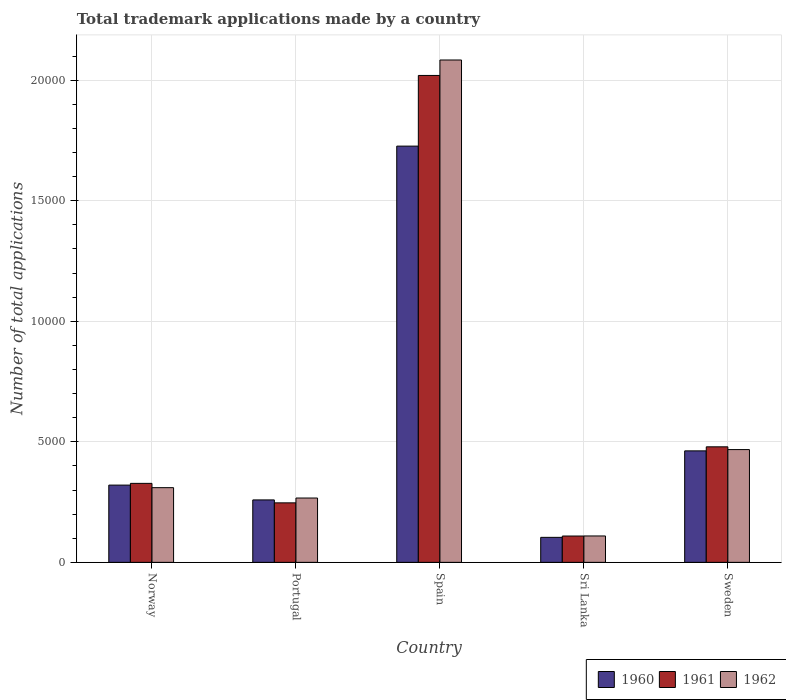How many different coloured bars are there?
Provide a succinct answer. 3. How many groups of bars are there?
Ensure brevity in your answer.  5. Are the number of bars per tick equal to the number of legend labels?
Your answer should be compact. Yes. How many bars are there on the 3rd tick from the left?
Your answer should be very brief. 3. What is the label of the 5th group of bars from the left?
Offer a terse response. Sweden. What is the number of applications made by in 1962 in Norway?
Your answer should be compact. 3098. Across all countries, what is the maximum number of applications made by in 1962?
Your response must be concise. 2.08e+04. Across all countries, what is the minimum number of applications made by in 1961?
Provide a succinct answer. 1092. In which country was the number of applications made by in 1962 maximum?
Make the answer very short. Spain. In which country was the number of applications made by in 1960 minimum?
Make the answer very short. Sri Lanka. What is the total number of applications made by in 1960 in the graph?
Provide a succinct answer. 2.87e+04. What is the difference between the number of applications made by in 1962 in Portugal and that in Spain?
Your response must be concise. -1.82e+04. What is the difference between the number of applications made by in 1960 in Spain and the number of applications made by in 1962 in Norway?
Provide a short and direct response. 1.42e+04. What is the average number of applications made by in 1961 per country?
Provide a succinct answer. 6364.4. In how many countries, is the number of applications made by in 1961 greater than 10000?
Your answer should be very brief. 1. What is the ratio of the number of applications made by in 1960 in Portugal to that in Sweden?
Keep it short and to the point. 0.56. Is the difference between the number of applications made by in 1962 in Portugal and Sweden greater than the difference between the number of applications made by in 1960 in Portugal and Sweden?
Your answer should be very brief. Yes. What is the difference between the highest and the second highest number of applications made by in 1961?
Your answer should be compact. -1.54e+04. What is the difference between the highest and the lowest number of applications made by in 1961?
Make the answer very short. 1.91e+04. Is the sum of the number of applications made by in 1960 in Norway and Sweden greater than the maximum number of applications made by in 1962 across all countries?
Keep it short and to the point. No. How many countries are there in the graph?
Offer a terse response. 5. What is the difference between two consecutive major ticks on the Y-axis?
Provide a short and direct response. 5000. Are the values on the major ticks of Y-axis written in scientific E-notation?
Provide a succinct answer. No. What is the title of the graph?
Make the answer very short. Total trademark applications made by a country. Does "1960" appear as one of the legend labels in the graph?
Provide a short and direct response. Yes. What is the label or title of the X-axis?
Provide a short and direct response. Country. What is the label or title of the Y-axis?
Give a very brief answer. Number of total applications. What is the Number of total applications in 1960 in Norway?
Provide a short and direct response. 3204. What is the Number of total applications of 1961 in Norway?
Your response must be concise. 3276. What is the Number of total applications of 1962 in Norway?
Ensure brevity in your answer.  3098. What is the Number of total applications of 1960 in Portugal?
Your response must be concise. 2590. What is the Number of total applications in 1961 in Portugal?
Give a very brief answer. 2468. What is the Number of total applications in 1962 in Portugal?
Provide a succinct answer. 2668. What is the Number of total applications of 1960 in Spain?
Offer a very short reply. 1.73e+04. What is the Number of total applications in 1961 in Spain?
Provide a short and direct response. 2.02e+04. What is the Number of total applications of 1962 in Spain?
Offer a very short reply. 2.08e+04. What is the Number of total applications in 1960 in Sri Lanka?
Make the answer very short. 1037. What is the Number of total applications in 1961 in Sri Lanka?
Offer a very short reply. 1092. What is the Number of total applications of 1962 in Sri Lanka?
Offer a terse response. 1095. What is the Number of total applications in 1960 in Sweden?
Provide a short and direct response. 4624. What is the Number of total applications in 1961 in Sweden?
Your response must be concise. 4792. What is the Number of total applications in 1962 in Sweden?
Offer a very short reply. 4677. Across all countries, what is the maximum Number of total applications of 1960?
Your response must be concise. 1.73e+04. Across all countries, what is the maximum Number of total applications in 1961?
Your answer should be compact. 2.02e+04. Across all countries, what is the maximum Number of total applications of 1962?
Make the answer very short. 2.08e+04. Across all countries, what is the minimum Number of total applications in 1960?
Offer a terse response. 1037. Across all countries, what is the minimum Number of total applications in 1961?
Offer a very short reply. 1092. Across all countries, what is the minimum Number of total applications of 1962?
Your answer should be compact. 1095. What is the total Number of total applications in 1960 in the graph?
Ensure brevity in your answer.  2.87e+04. What is the total Number of total applications in 1961 in the graph?
Provide a short and direct response. 3.18e+04. What is the total Number of total applications of 1962 in the graph?
Make the answer very short. 3.24e+04. What is the difference between the Number of total applications of 1960 in Norway and that in Portugal?
Your answer should be compact. 614. What is the difference between the Number of total applications of 1961 in Norway and that in Portugal?
Make the answer very short. 808. What is the difference between the Number of total applications in 1962 in Norway and that in Portugal?
Your answer should be compact. 430. What is the difference between the Number of total applications of 1960 in Norway and that in Spain?
Your answer should be compact. -1.41e+04. What is the difference between the Number of total applications in 1961 in Norway and that in Spain?
Make the answer very short. -1.69e+04. What is the difference between the Number of total applications of 1962 in Norway and that in Spain?
Your answer should be compact. -1.77e+04. What is the difference between the Number of total applications in 1960 in Norway and that in Sri Lanka?
Your answer should be compact. 2167. What is the difference between the Number of total applications in 1961 in Norway and that in Sri Lanka?
Offer a terse response. 2184. What is the difference between the Number of total applications of 1962 in Norway and that in Sri Lanka?
Your response must be concise. 2003. What is the difference between the Number of total applications in 1960 in Norway and that in Sweden?
Your answer should be compact. -1420. What is the difference between the Number of total applications in 1961 in Norway and that in Sweden?
Provide a succinct answer. -1516. What is the difference between the Number of total applications of 1962 in Norway and that in Sweden?
Ensure brevity in your answer.  -1579. What is the difference between the Number of total applications of 1960 in Portugal and that in Spain?
Offer a very short reply. -1.47e+04. What is the difference between the Number of total applications in 1961 in Portugal and that in Spain?
Offer a terse response. -1.77e+04. What is the difference between the Number of total applications in 1962 in Portugal and that in Spain?
Keep it short and to the point. -1.82e+04. What is the difference between the Number of total applications in 1960 in Portugal and that in Sri Lanka?
Make the answer very short. 1553. What is the difference between the Number of total applications in 1961 in Portugal and that in Sri Lanka?
Provide a succinct answer. 1376. What is the difference between the Number of total applications of 1962 in Portugal and that in Sri Lanka?
Ensure brevity in your answer.  1573. What is the difference between the Number of total applications in 1960 in Portugal and that in Sweden?
Make the answer very short. -2034. What is the difference between the Number of total applications in 1961 in Portugal and that in Sweden?
Make the answer very short. -2324. What is the difference between the Number of total applications in 1962 in Portugal and that in Sweden?
Offer a terse response. -2009. What is the difference between the Number of total applications in 1960 in Spain and that in Sri Lanka?
Give a very brief answer. 1.62e+04. What is the difference between the Number of total applications in 1961 in Spain and that in Sri Lanka?
Offer a terse response. 1.91e+04. What is the difference between the Number of total applications in 1962 in Spain and that in Sri Lanka?
Ensure brevity in your answer.  1.97e+04. What is the difference between the Number of total applications in 1960 in Spain and that in Sweden?
Give a very brief answer. 1.26e+04. What is the difference between the Number of total applications of 1961 in Spain and that in Sweden?
Ensure brevity in your answer.  1.54e+04. What is the difference between the Number of total applications of 1962 in Spain and that in Sweden?
Give a very brief answer. 1.62e+04. What is the difference between the Number of total applications in 1960 in Sri Lanka and that in Sweden?
Your response must be concise. -3587. What is the difference between the Number of total applications of 1961 in Sri Lanka and that in Sweden?
Your response must be concise. -3700. What is the difference between the Number of total applications of 1962 in Sri Lanka and that in Sweden?
Keep it short and to the point. -3582. What is the difference between the Number of total applications of 1960 in Norway and the Number of total applications of 1961 in Portugal?
Offer a terse response. 736. What is the difference between the Number of total applications of 1960 in Norway and the Number of total applications of 1962 in Portugal?
Your answer should be very brief. 536. What is the difference between the Number of total applications of 1961 in Norway and the Number of total applications of 1962 in Portugal?
Your response must be concise. 608. What is the difference between the Number of total applications in 1960 in Norway and the Number of total applications in 1961 in Spain?
Provide a short and direct response. -1.70e+04. What is the difference between the Number of total applications of 1960 in Norway and the Number of total applications of 1962 in Spain?
Give a very brief answer. -1.76e+04. What is the difference between the Number of total applications of 1961 in Norway and the Number of total applications of 1962 in Spain?
Offer a terse response. -1.76e+04. What is the difference between the Number of total applications in 1960 in Norway and the Number of total applications in 1961 in Sri Lanka?
Provide a short and direct response. 2112. What is the difference between the Number of total applications of 1960 in Norway and the Number of total applications of 1962 in Sri Lanka?
Make the answer very short. 2109. What is the difference between the Number of total applications in 1961 in Norway and the Number of total applications in 1962 in Sri Lanka?
Provide a short and direct response. 2181. What is the difference between the Number of total applications in 1960 in Norway and the Number of total applications in 1961 in Sweden?
Ensure brevity in your answer.  -1588. What is the difference between the Number of total applications of 1960 in Norway and the Number of total applications of 1962 in Sweden?
Ensure brevity in your answer.  -1473. What is the difference between the Number of total applications of 1961 in Norway and the Number of total applications of 1962 in Sweden?
Provide a short and direct response. -1401. What is the difference between the Number of total applications in 1960 in Portugal and the Number of total applications in 1961 in Spain?
Offer a terse response. -1.76e+04. What is the difference between the Number of total applications in 1960 in Portugal and the Number of total applications in 1962 in Spain?
Make the answer very short. -1.82e+04. What is the difference between the Number of total applications in 1961 in Portugal and the Number of total applications in 1962 in Spain?
Offer a terse response. -1.84e+04. What is the difference between the Number of total applications of 1960 in Portugal and the Number of total applications of 1961 in Sri Lanka?
Offer a terse response. 1498. What is the difference between the Number of total applications in 1960 in Portugal and the Number of total applications in 1962 in Sri Lanka?
Provide a succinct answer. 1495. What is the difference between the Number of total applications in 1961 in Portugal and the Number of total applications in 1962 in Sri Lanka?
Your answer should be very brief. 1373. What is the difference between the Number of total applications in 1960 in Portugal and the Number of total applications in 1961 in Sweden?
Offer a terse response. -2202. What is the difference between the Number of total applications of 1960 in Portugal and the Number of total applications of 1962 in Sweden?
Ensure brevity in your answer.  -2087. What is the difference between the Number of total applications of 1961 in Portugal and the Number of total applications of 1962 in Sweden?
Make the answer very short. -2209. What is the difference between the Number of total applications of 1960 in Spain and the Number of total applications of 1961 in Sri Lanka?
Provide a succinct answer. 1.62e+04. What is the difference between the Number of total applications of 1960 in Spain and the Number of total applications of 1962 in Sri Lanka?
Offer a very short reply. 1.62e+04. What is the difference between the Number of total applications of 1961 in Spain and the Number of total applications of 1962 in Sri Lanka?
Your response must be concise. 1.91e+04. What is the difference between the Number of total applications of 1960 in Spain and the Number of total applications of 1961 in Sweden?
Your answer should be very brief. 1.25e+04. What is the difference between the Number of total applications of 1960 in Spain and the Number of total applications of 1962 in Sweden?
Make the answer very short. 1.26e+04. What is the difference between the Number of total applications in 1961 in Spain and the Number of total applications in 1962 in Sweden?
Your answer should be compact. 1.55e+04. What is the difference between the Number of total applications in 1960 in Sri Lanka and the Number of total applications in 1961 in Sweden?
Keep it short and to the point. -3755. What is the difference between the Number of total applications in 1960 in Sri Lanka and the Number of total applications in 1962 in Sweden?
Make the answer very short. -3640. What is the difference between the Number of total applications of 1961 in Sri Lanka and the Number of total applications of 1962 in Sweden?
Your response must be concise. -3585. What is the average Number of total applications in 1960 per country?
Your response must be concise. 5743.6. What is the average Number of total applications of 1961 per country?
Give a very brief answer. 6364.4. What is the average Number of total applications in 1962 per country?
Ensure brevity in your answer.  6474.6. What is the difference between the Number of total applications in 1960 and Number of total applications in 1961 in Norway?
Keep it short and to the point. -72. What is the difference between the Number of total applications of 1960 and Number of total applications of 1962 in Norway?
Your answer should be very brief. 106. What is the difference between the Number of total applications of 1961 and Number of total applications of 1962 in Norway?
Keep it short and to the point. 178. What is the difference between the Number of total applications in 1960 and Number of total applications in 1961 in Portugal?
Provide a short and direct response. 122. What is the difference between the Number of total applications of 1960 and Number of total applications of 1962 in Portugal?
Make the answer very short. -78. What is the difference between the Number of total applications of 1961 and Number of total applications of 1962 in Portugal?
Offer a very short reply. -200. What is the difference between the Number of total applications of 1960 and Number of total applications of 1961 in Spain?
Provide a short and direct response. -2931. What is the difference between the Number of total applications in 1960 and Number of total applications in 1962 in Spain?
Provide a succinct answer. -3572. What is the difference between the Number of total applications of 1961 and Number of total applications of 1962 in Spain?
Provide a succinct answer. -641. What is the difference between the Number of total applications in 1960 and Number of total applications in 1961 in Sri Lanka?
Offer a terse response. -55. What is the difference between the Number of total applications of 1960 and Number of total applications of 1962 in Sri Lanka?
Make the answer very short. -58. What is the difference between the Number of total applications of 1960 and Number of total applications of 1961 in Sweden?
Ensure brevity in your answer.  -168. What is the difference between the Number of total applications in 1960 and Number of total applications in 1962 in Sweden?
Your response must be concise. -53. What is the difference between the Number of total applications in 1961 and Number of total applications in 1962 in Sweden?
Your answer should be compact. 115. What is the ratio of the Number of total applications of 1960 in Norway to that in Portugal?
Your response must be concise. 1.24. What is the ratio of the Number of total applications of 1961 in Norway to that in Portugal?
Offer a terse response. 1.33. What is the ratio of the Number of total applications in 1962 in Norway to that in Portugal?
Offer a terse response. 1.16. What is the ratio of the Number of total applications in 1960 in Norway to that in Spain?
Provide a short and direct response. 0.19. What is the ratio of the Number of total applications in 1961 in Norway to that in Spain?
Keep it short and to the point. 0.16. What is the ratio of the Number of total applications in 1962 in Norway to that in Spain?
Offer a terse response. 0.15. What is the ratio of the Number of total applications in 1960 in Norway to that in Sri Lanka?
Provide a succinct answer. 3.09. What is the ratio of the Number of total applications of 1961 in Norway to that in Sri Lanka?
Keep it short and to the point. 3. What is the ratio of the Number of total applications in 1962 in Norway to that in Sri Lanka?
Make the answer very short. 2.83. What is the ratio of the Number of total applications in 1960 in Norway to that in Sweden?
Provide a short and direct response. 0.69. What is the ratio of the Number of total applications of 1961 in Norway to that in Sweden?
Provide a short and direct response. 0.68. What is the ratio of the Number of total applications in 1962 in Norway to that in Sweden?
Provide a short and direct response. 0.66. What is the ratio of the Number of total applications of 1961 in Portugal to that in Spain?
Your answer should be very brief. 0.12. What is the ratio of the Number of total applications of 1962 in Portugal to that in Spain?
Offer a terse response. 0.13. What is the ratio of the Number of total applications in 1960 in Portugal to that in Sri Lanka?
Give a very brief answer. 2.5. What is the ratio of the Number of total applications in 1961 in Portugal to that in Sri Lanka?
Your response must be concise. 2.26. What is the ratio of the Number of total applications in 1962 in Portugal to that in Sri Lanka?
Give a very brief answer. 2.44. What is the ratio of the Number of total applications of 1960 in Portugal to that in Sweden?
Your response must be concise. 0.56. What is the ratio of the Number of total applications of 1961 in Portugal to that in Sweden?
Your answer should be very brief. 0.52. What is the ratio of the Number of total applications in 1962 in Portugal to that in Sweden?
Your answer should be very brief. 0.57. What is the ratio of the Number of total applications in 1960 in Spain to that in Sri Lanka?
Your response must be concise. 16.65. What is the ratio of the Number of total applications of 1961 in Spain to that in Sri Lanka?
Your response must be concise. 18.49. What is the ratio of the Number of total applications of 1962 in Spain to that in Sri Lanka?
Your response must be concise. 19.03. What is the ratio of the Number of total applications of 1960 in Spain to that in Sweden?
Ensure brevity in your answer.  3.73. What is the ratio of the Number of total applications of 1961 in Spain to that in Sweden?
Your answer should be very brief. 4.21. What is the ratio of the Number of total applications of 1962 in Spain to that in Sweden?
Keep it short and to the point. 4.45. What is the ratio of the Number of total applications in 1960 in Sri Lanka to that in Sweden?
Your response must be concise. 0.22. What is the ratio of the Number of total applications of 1961 in Sri Lanka to that in Sweden?
Offer a very short reply. 0.23. What is the ratio of the Number of total applications of 1962 in Sri Lanka to that in Sweden?
Offer a very short reply. 0.23. What is the difference between the highest and the second highest Number of total applications of 1960?
Your answer should be compact. 1.26e+04. What is the difference between the highest and the second highest Number of total applications of 1961?
Provide a succinct answer. 1.54e+04. What is the difference between the highest and the second highest Number of total applications of 1962?
Keep it short and to the point. 1.62e+04. What is the difference between the highest and the lowest Number of total applications of 1960?
Keep it short and to the point. 1.62e+04. What is the difference between the highest and the lowest Number of total applications in 1961?
Give a very brief answer. 1.91e+04. What is the difference between the highest and the lowest Number of total applications in 1962?
Your answer should be compact. 1.97e+04. 